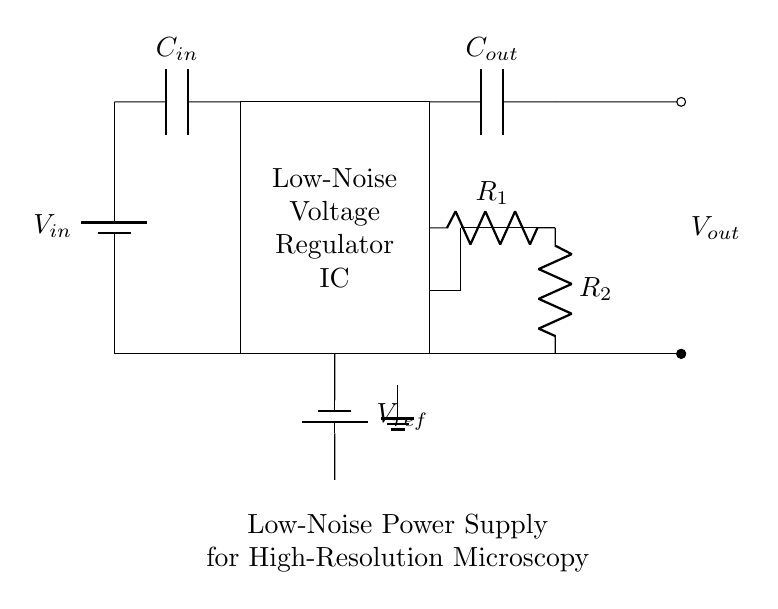What is the input voltage of this circuit? The diagram indicates an input voltage denoted as V in, represented at the battery symbol on the left side. It does not specify a numeric value.
Answer: V in What type of regulator is depicted in the circuit? The central rectangle labeled "Low-Noise Voltage Regulator IC" indicates that this circuit is a low-noise voltage regulator.
Answer: Low-noise voltage regulator How many resistors are present in the feedback network? The feedback network consists of a total of two resistors, R1 and R2, as shown in the circuit diagram.
Answer: 2 What is the role of the output capacitor? The output capacitor, labeled C out, is used to smooth the output voltage and minimize noise, ensuring stable voltage levels for sensitive applications like microscopy.
Answer: Smoothing What is the reference voltage of the circuit? The reference voltage is denoted as V ref, indicated by the battery symbol connected to the voltage regulator IC at the bottom. The diagram does not specify a numeric value.
Answer: V ref What is the output voltage of this circuit? The output voltage, denoted as V out, is represented by the connection to the right side of the circuit, which leads to external components, but no numeric value is provided in the diagram.
Answer: V out 